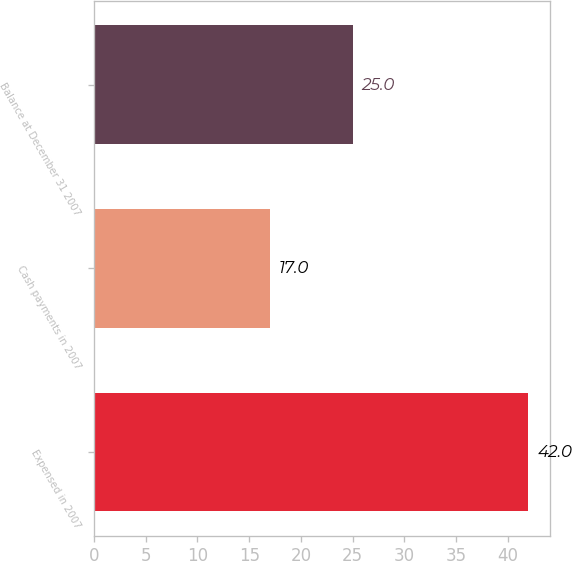<chart> <loc_0><loc_0><loc_500><loc_500><bar_chart><fcel>Expensed in 2007<fcel>Cash payments in 2007<fcel>Balance at December 31 2007<nl><fcel>42<fcel>17<fcel>25<nl></chart> 